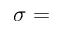<formula> <loc_0><loc_0><loc_500><loc_500>\sigma =</formula> 